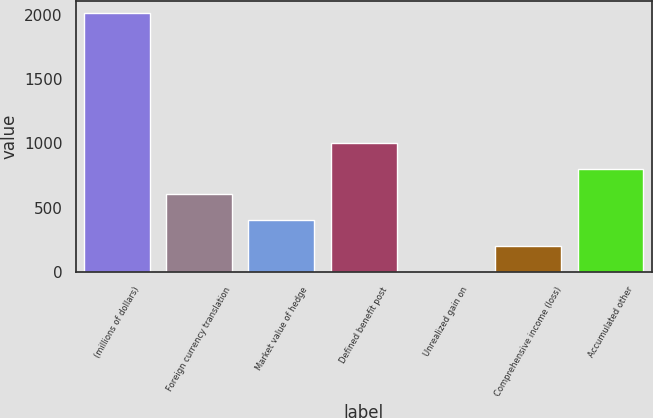<chart> <loc_0><loc_0><loc_500><loc_500><bar_chart><fcel>(millions of dollars)<fcel>Foreign currency translation<fcel>Market value of hedge<fcel>Defined benefit post<fcel>Unrealized gain on<fcel>Comprehensive income (loss)<fcel>Accumulated other<nl><fcel>2011<fcel>604.07<fcel>403.08<fcel>1006.05<fcel>1.1<fcel>202.09<fcel>805.06<nl></chart> 